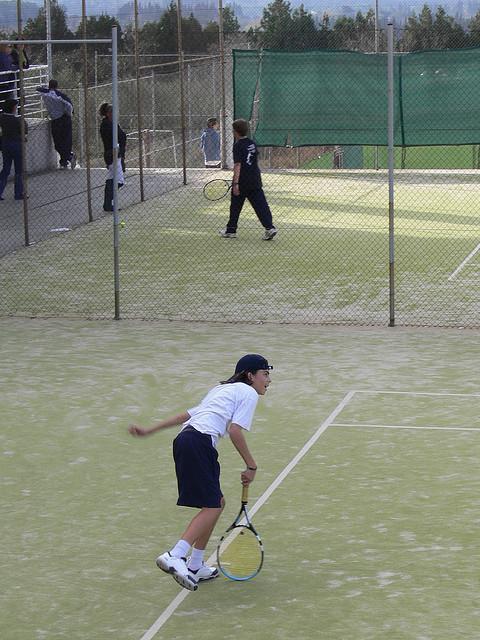How many rackets are shown?
Give a very brief answer. 2. How many people can be seen?
Give a very brief answer. 3. How many zebras are there?
Give a very brief answer. 0. 